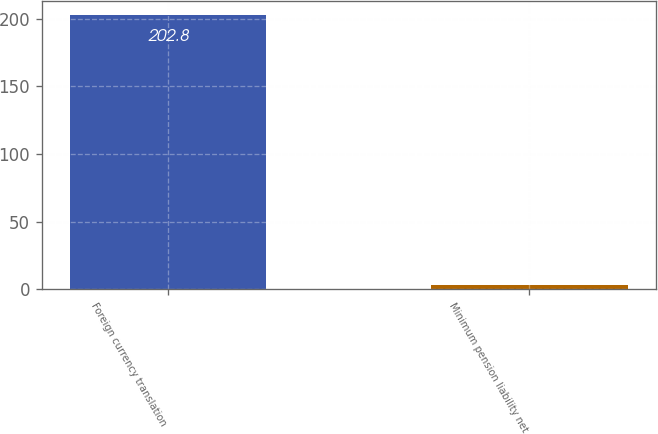Convert chart. <chart><loc_0><loc_0><loc_500><loc_500><bar_chart><fcel>Foreign currency translation<fcel>Minimum pension liability net<nl><fcel>202.8<fcel>3.3<nl></chart> 